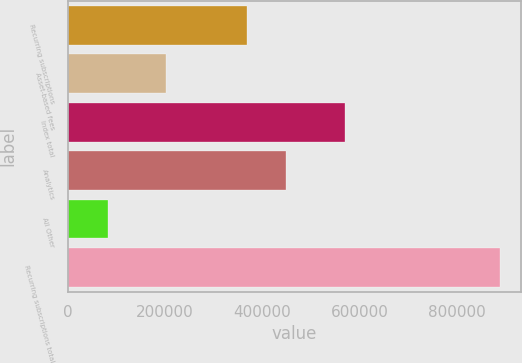Convert chart to OTSL. <chart><loc_0><loc_0><loc_500><loc_500><bar_chart><fcel>Recurring subscriptions<fcel>Asset-based fees<fcel>Index total<fcel>Analytics<fcel>All Other<fcel>Recurring subscriptions total<nl><fcel>368855<fcel>201047<fcel>569902<fcel>449408<fcel>82677<fcel>888203<nl></chart> 